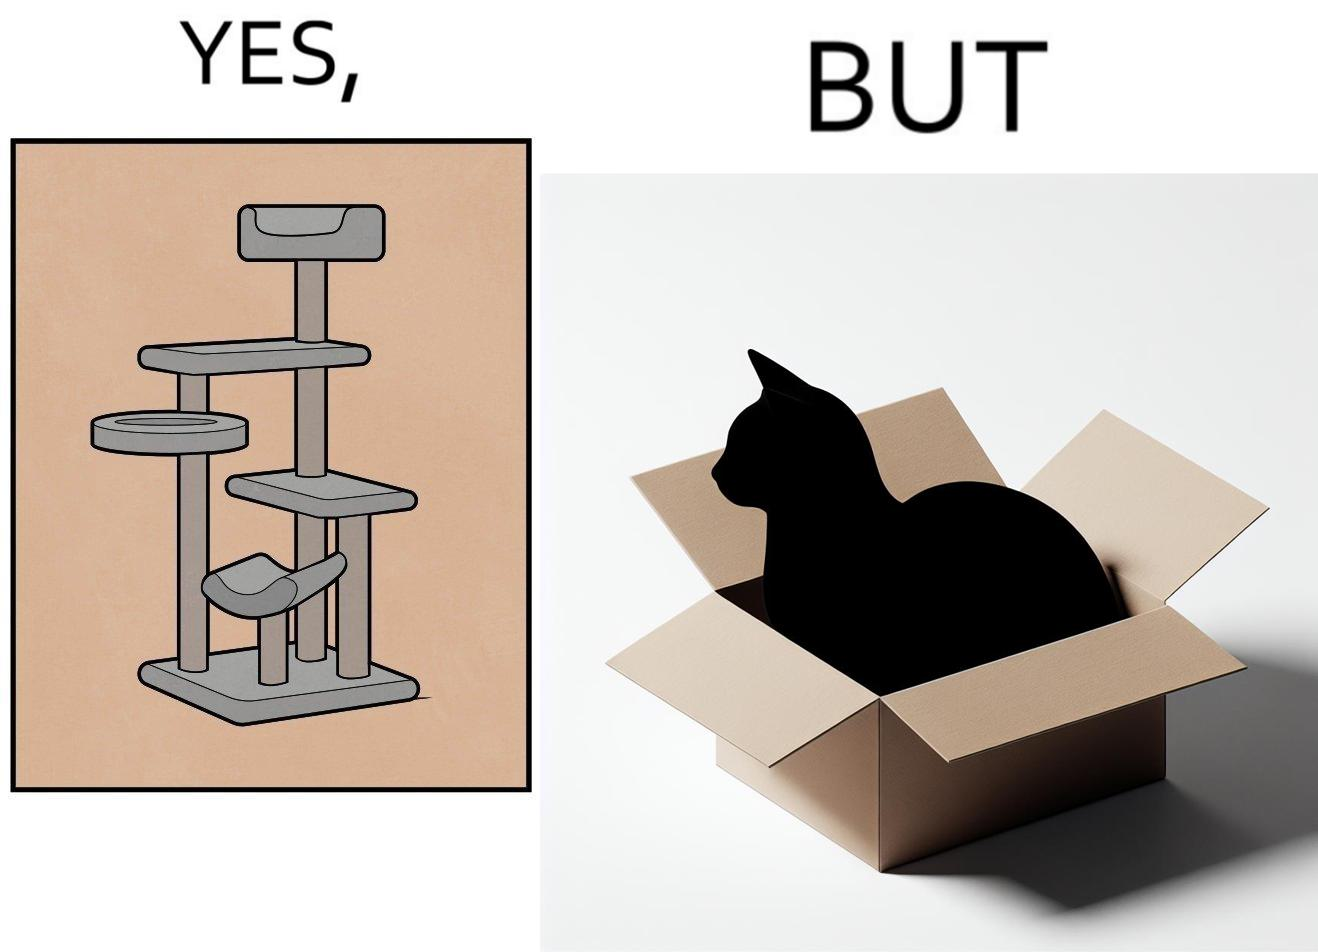Explain the humor or irony in this image. The images are funny since even though a cat tree is bought for cats to play with, cats would usually rather play with inexpensive cardboard boxes because they enjoy it more 